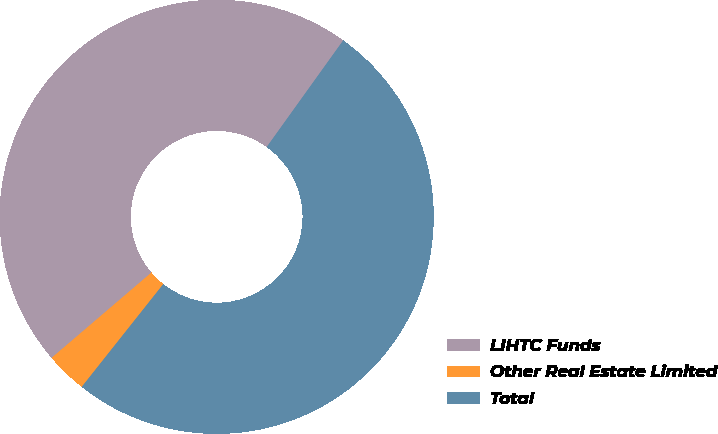Convert chart. <chart><loc_0><loc_0><loc_500><loc_500><pie_chart><fcel>LIHTC Funds<fcel>Other Real Estate Limited<fcel>Total<nl><fcel>46.16%<fcel>3.07%<fcel>50.77%<nl></chart> 